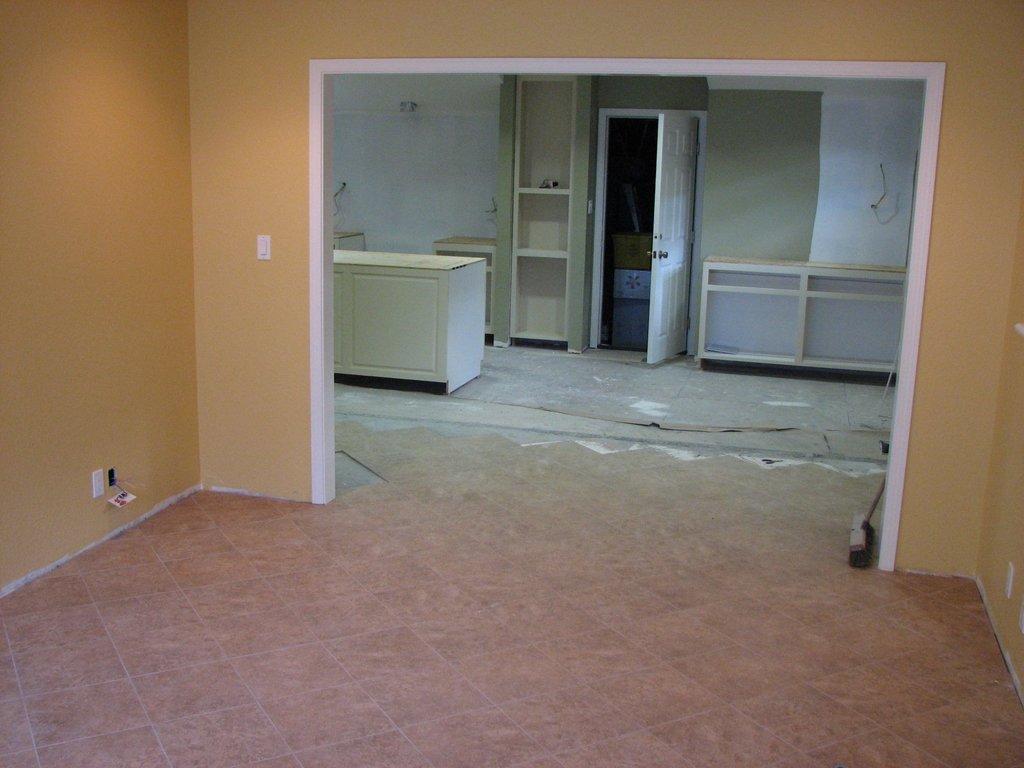Please provide a concise description of this image. In this image, I can see two rooms. There are shelves, cupboard, door, cardboard boxes and the walls. 